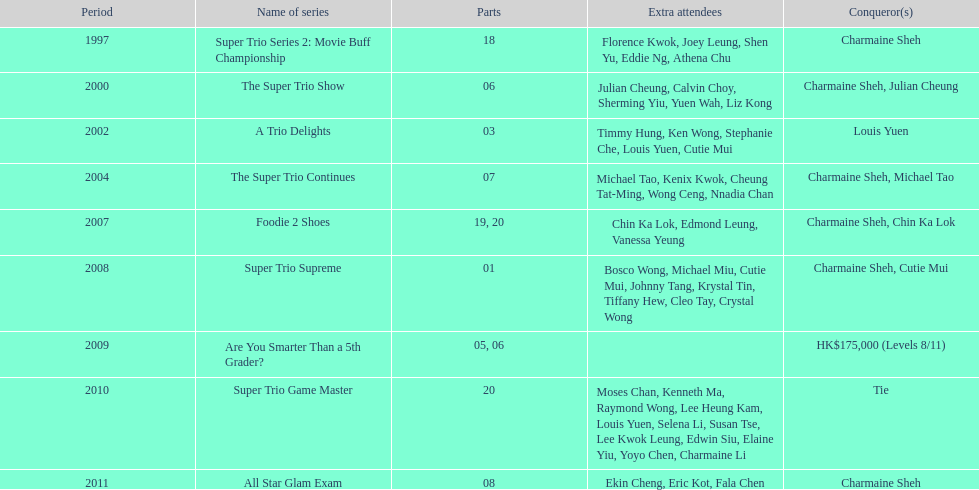How many of shows had at least 5 episodes? 7. 